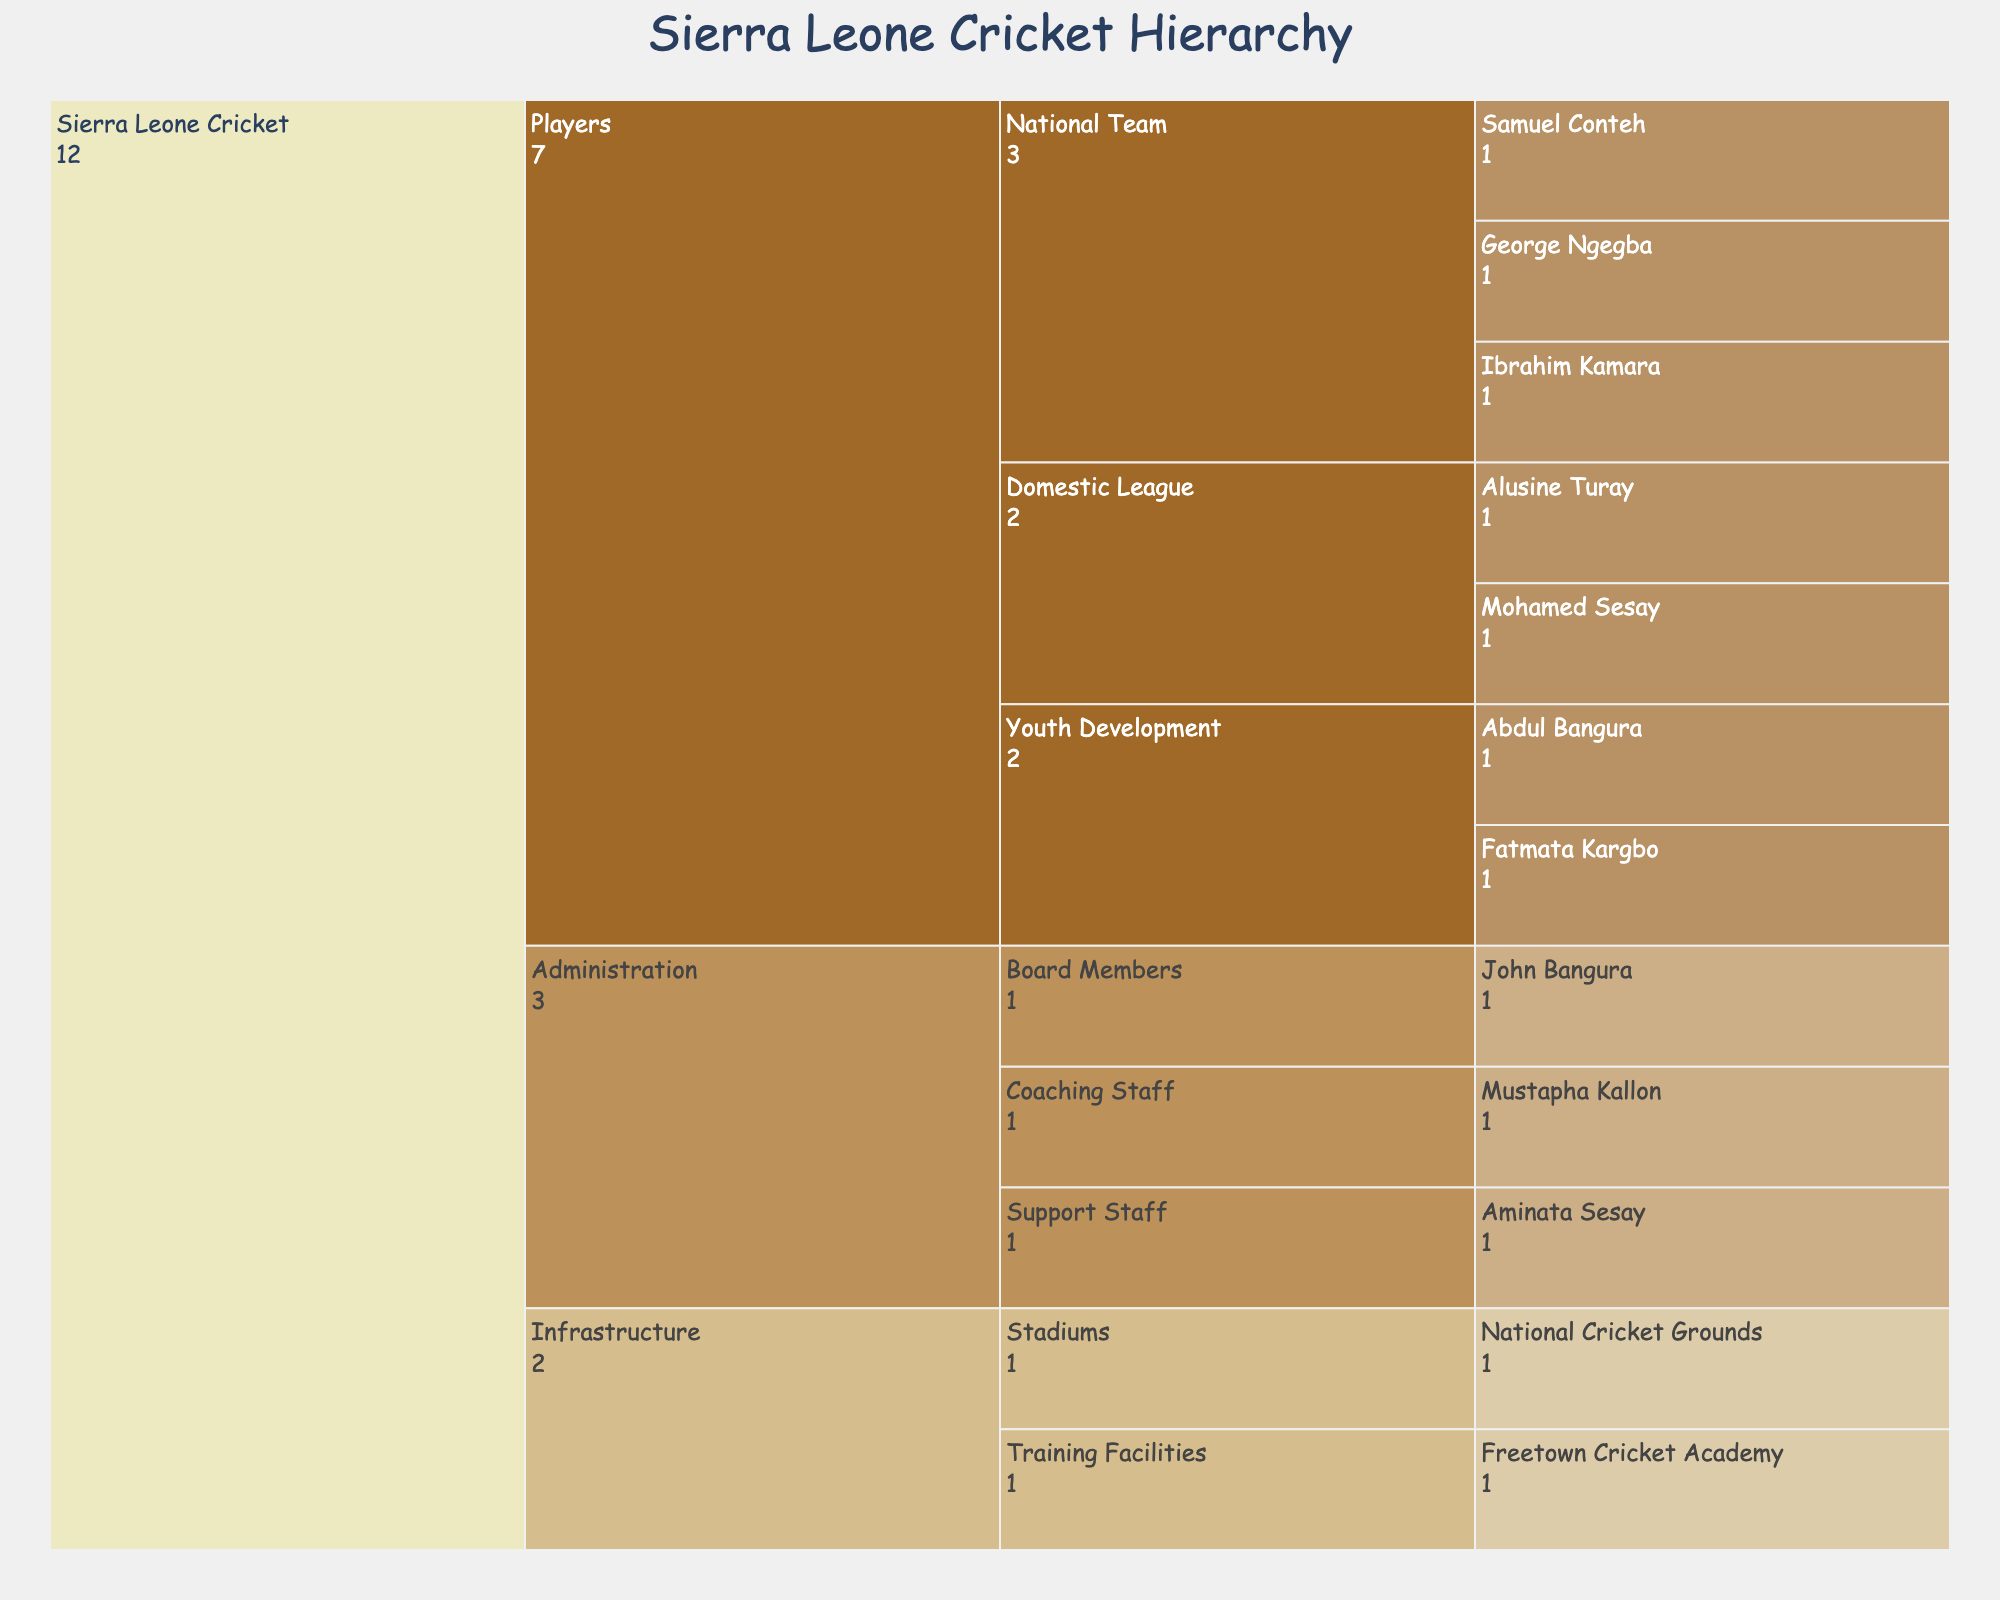How many players are in the Sierra Leone national cricket team? The "National Team" falls under the "Players" category, and under it, there are three players listed: George Ngegba, Ibrahim Kamara, and Samuel Conteh. So, counting these players, we get a total of 3.
Answer: 3 Who are the members of the Sierra Leone cricket coaching staff? The "Coaching Staff" is a subcategory under "Administration." There is one person listed in this subcategory: Mustapha Kallon.
Answer: Mustapha Kallon What is the title of the Icicle Chart? The title of the chart is prominently displayed at the top of the figure. It reads "Sierra Leone Cricket Hierarchy".
Answer: Sierra Leone Cricket Hierarchy Which category has more subcategories: Administration or Players? The "Administration" category has three subcategories: Board Members, Coaching Staff, and Support Staff. The "Players" category has three subcategories: National Team, Domestic League, and Youth Development. Both categories have an equal number of subcategories, 3 each.
Answer: Equal, 3 each Which player is part of the Sierra Leone cricket Youth Development team? Under the "Youth Development" subcategory in the "Players" category, there are two players listed: Fatmata Kargbo and Abdul Bangura.
Answer: Fatmata Kargbo and Abdul Bangura What are the constituents of the "Infrastructure" category? The "Infrastructure" category is divided into two subcategories: Stadiums and Training Facilities. The "Stadiums" subcategory contains "National Cricket Grounds", and the "Training Facilities" subcategory contains "Freetown Cricket Academy."
Answer: Stadiums and Training Facilities How many total individuals are listed in the Administration category? Under the "Administration" category, there are three subcategories: Board Members, Coaching Staff, and Support Staff. Each subcategory has one individual listed: John Bangura, Mustapha Kallon, and Aminata Sesay, respectively, summing up to 3 individuals.
Answer: 3 Compare the number of players in the National Team and the Domestic League. Which has more players? The "National Team" subcategory lists 3 players: George Ngegba, Ibrahim Kamara, and Samuel Conteh. The "Domestic League" subcategory lists 2 players: Alusine Turay and Mohamed Sesay. Hence, the National Team has more players.
Answer: National Team Who is listed under the "Board Members" subcategory of the Administration? Under the "Board Members" subcategory in the "Administration" category, the person listed is John Bangura.
Answer: John Bangura 